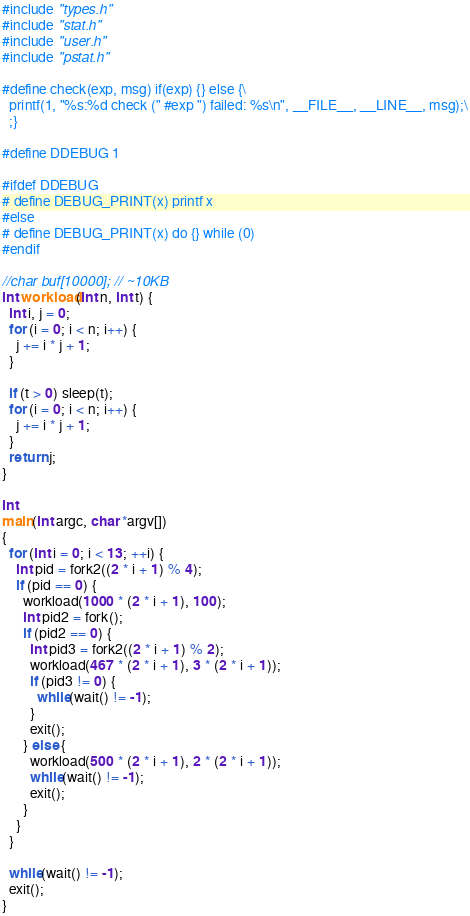Convert code to text. <code><loc_0><loc_0><loc_500><loc_500><_C_>#include "types.h"
#include "stat.h"
#include "user.h"
#include "pstat.h"

#define check(exp, msg) if(exp) {} else {\
  printf(1, "%s:%d check (" #exp ") failed: %s\n", __FILE__, __LINE__, msg);\
  ;}

#define DDEBUG 1

#ifdef DDEBUG
# define DEBUG_PRINT(x) printf x
#else
# define DEBUG_PRINT(x) do {} while (0)
#endif

//char buf[10000]; // ~10KB
int workload(int n, int t) {
  int i, j = 0;
  for (i = 0; i < n; i++) {
    j += i * j + 1;
  }

  if (t > 0) sleep(t);
  for (i = 0; i < n; i++) {
    j += i * j + 1;
  }
  return j;
}

int
main(int argc, char *argv[])
{
  for (int i = 0; i < 13; ++i) {
    int pid = fork2((2 * i + 1) % 4);
    if (pid == 0) {
      workload(1000 * (2 * i + 1), 100);
      int pid2 = fork();
      if (pid2 == 0) {
        int pid3 = fork2((2 * i + 1) % 2);
        workload(467 * (2 * i + 1), 3 * (2 * i + 1));
        if (pid3 != 0) {
          while(wait() != -1);
        }
        exit();
      } else {
        workload(500 * (2 * i + 1), 2 * (2 * i + 1));
        while(wait() != -1);
        exit();
      }
    }
  }

  while(wait() != -1);
  exit();
}
</code> 